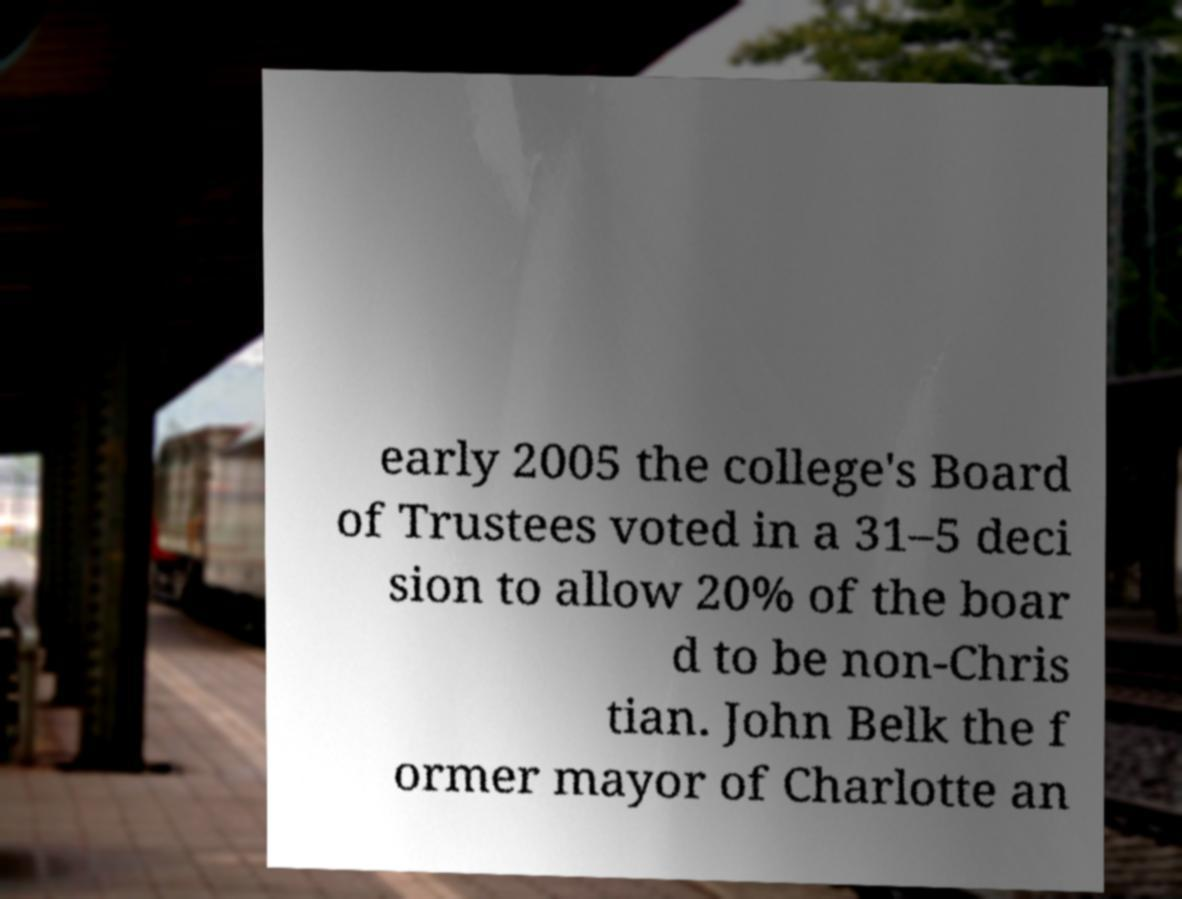There's text embedded in this image that I need extracted. Can you transcribe it verbatim? early 2005 the college's Board of Trustees voted in a 31–5 deci sion to allow 20% of the boar d to be non-Chris tian. John Belk the f ormer mayor of Charlotte an 